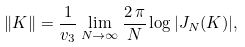Convert formula to latex. <formula><loc_0><loc_0><loc_500><loc_500>\| K \| = \frac { 1 } { v _ { 3 } } \lim _ { N \to \infty } \frac { 2 \, \pi } { N } \log | J _ { N } ( K ) | ,</formula> 